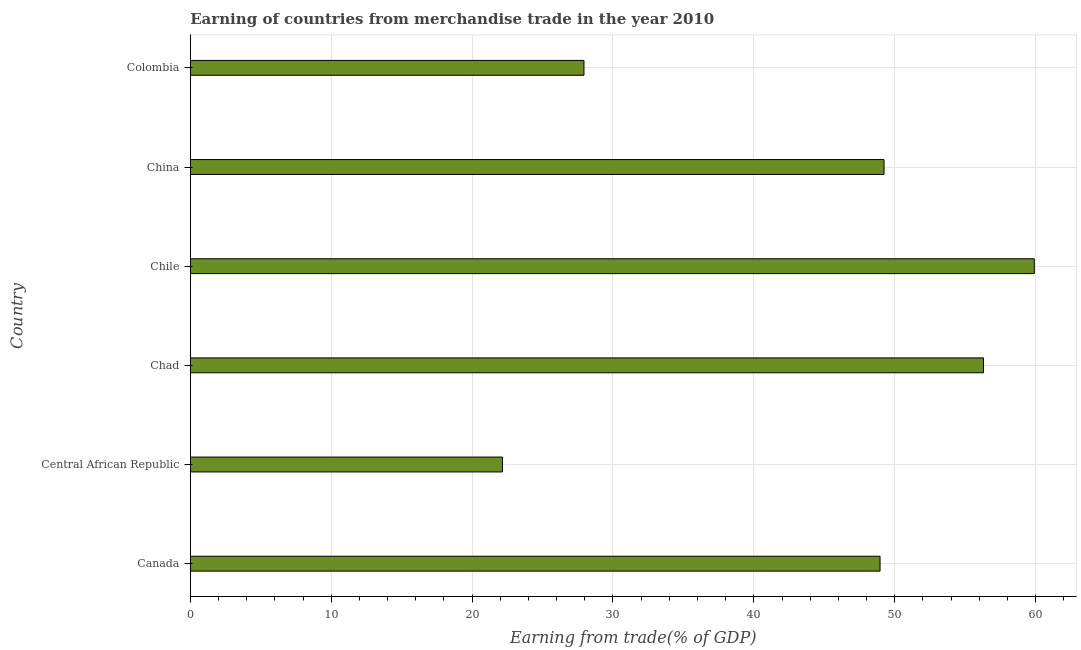Does the graph contain any zero values?
Your response must be concise. No. What is the title of the graph?
Offer a very short reply. Earning of countries from merchandise trade in the year 2010. What is the label or title of the X-axis?
Your answer should be very brief. Earning from trade(% of GDP). What is the label or title of the Y-axis?
Your response must be concise. Country. What is the earning from merchandise trade in Chile?
Keep it short and to the point. 59.9. Across all countries, what is the maximum earning from merchandise trade?
Your answer should be very brief. 59.9. Across all countries, what is the minimum earning from merchandise trade?
Give a very brief answer. 22.15. In which country was the earning from merchandise trade maximum?
Give a very brief answer. Chile. In which country was the earning from merchandise trade minimum?
Keep it short and to the point. Central African Republic. What is the sum of the earning from merchandise trade?
Keep it short and to the point. 264.5. What is the difference between the earning from merchandise trade in Central African Republic and Chad?
Provide a succinct answer. -34.14. What is the average earning from merchandise trade per country?
Your answer should be compact. 44.08. What is the median earning from merchandise trade?
Provide a short and direct response. 49.1. In how many countries, is the earning from merchandise trade greater than 10 %?
Ensure brevity in your answer.  6. What is the ratio of the earning from merchandise trade in Chad to that in Colombia?
Your response must be concise. 2.02. Is the earning from merchandise trade in Chile less than that in China?
Ensure brevity in your answer.  No. What is the difference between the highest and the second highest earning from merchandise trade?
Keep it short and to the point. 3.61. What is the difference between the highest and the lowest earning from merchandise trade?
Your answer should be very brief. 37.75. In how many countries, is the earning from merchandise trade greater than the average earning from merchandise trade taken over all countries?
Make the answer very short. 4. Are all the bars in the graph horizontal?
Ensure brevity in your answer.  Yes. How many countries are there in the graph?
Ensure brevity in your answer.  6. Are the values on the major ticks of X-axis written in scientific E-notation?
Your answer should be compact. No. What is the Earning from trade(% of GDP) in Canada?
Your answer should be compact. 48.96. What is the Earning from trade(% of GDP) of Central African Republic?
Offer a very short reply. 22.15. What is the Earning from trade(% of GDP) of Chad?
Make the answer very short. 56.3. What is the Earning from trade(% of GDP) of Chile?
Offer a terse response. 59.9. What is the Earning from trade(% of GDP) in China?
Give a very brief answer. 49.24. What is the Earning from trade(% of GDP) of Colombia?
Your answer should be very brief. 27.94. What is the difference between the Earning from trade(% of GDP) in Canada and Central African Republic?
Your response must be concise. 26.8. What is the difference between the Earning from trade(% of GDP) in Canada and Chad?
Make the answer very short. -7.34. What is the difference between the Earning from trade(% of GDP) in Canada and Chile?
Your answer should be compact. -10.95. What is the difference between the Earning from trade(% of GDP) in Canada and China?
Provide a succinct answer. -0.28. What is the difference between the Earning from trade(% of GDP) in Canada and Colombia?
Make the answer very short. 21.01. What is the difference between the Earning from trade(% of GDP) in Central African Republic and Chad?
Give a very brief answer. -34.14. What is the difference between the Earning from trade(% of GDP) in Central African Republic and Chile?
Your answer should be compact. -37.75. What is the difference between the Earning from trade(% of GDP) in Central African Republic and China?
Provide a short and direct response. -27.09. What is the difference between the Earning from trade(% of GDP) in Central African Republic and Colombia?
Offer a very short reply. -5.79. What is the difference between the Earning from trade(% of GDP) in Chad and Chile?
Your answer should be compact. -3.61. What is the difference between the Earning from trade(% of GDP) in Chad and China?
Provide a short and direct response. 7.06. What is the difference between the Earning from trade(% of GDP) in Chad and Colombia?
Provide a short and direct response. 28.36. What is the difference between the Earning from trade(% of GDP) in Chile and China?
Your answer should be very brief. 10.66. What is the difference between the Earning from trade(% of GDP) in Chile and Colombia?
Make the answer very short. 31.96. What is the difference between the Earning from trade(% of GDP) in China and Colombia?
Your answer should be compact. 21.3. What is the ratio of the Earning from trade(% of GDP) in Canada to that in Central African Republic?
Keep it short and to the point. 2.21. What is the ratio of the Earning from trade(% of GDP) in Canada to that in Chad?
Offer a very short reply. 0.87. What is the ratio of the Earning from trade(% of GDP) in Canada to that in Chile?
Provide a short and direct response. 0.82. What is the ratio of the Earning from trade(% of GDP) in Canada to that in China?
Give a very brief answer. 0.99. What is the ratio of the Earning from trade(% of GDP) in Canada to that in Colombia?
Your answer should be compact. 1.75. What is the ratio of the Earning from trade(% of GDP) in Central African Republic to that in Chad?
Ensure brevity in your answer.  0.39. What is the ratio of the Earning from trade(% of GDP) in Central African Republic to that in Chile?
Ensure brevity in your answer.  0.37. What is the ratio of the Earning from trade(% of GDP) in Central African Republic to that in China?
Keep it short and to the point. 0.45. What is the ratio of the Earning from trade(% of GDP) in Central African Republic to that in Colombia?
Give a very brief answer. 0.79. What is the ratio of the Earning from trade(% of GDP) in Chad to that in Chile?
Keep it short and to the point. 0.94. What is the ratio of the Earning from trade(% of GDP) in Chad to that in China?
Provide a short and direct response. 1.14. What is the ratio of the Earning from trade(% of GDP) in Chad to that in Colombia?
Provide a short and direct response. 2.02. What is the ratio of the Earning from trade(% of GDP) in Chile to that in China?
Make the answer very short. 1.22. What is the ratio of the Earning from trade(% of GDP) in Chile to that in Colombia?
Provide a succinct answer. 2.14. What is the ratio of the Earning from trade(% of GDP) in China to that in Colombia?
Ensure brevity in your answer.  1.76. 